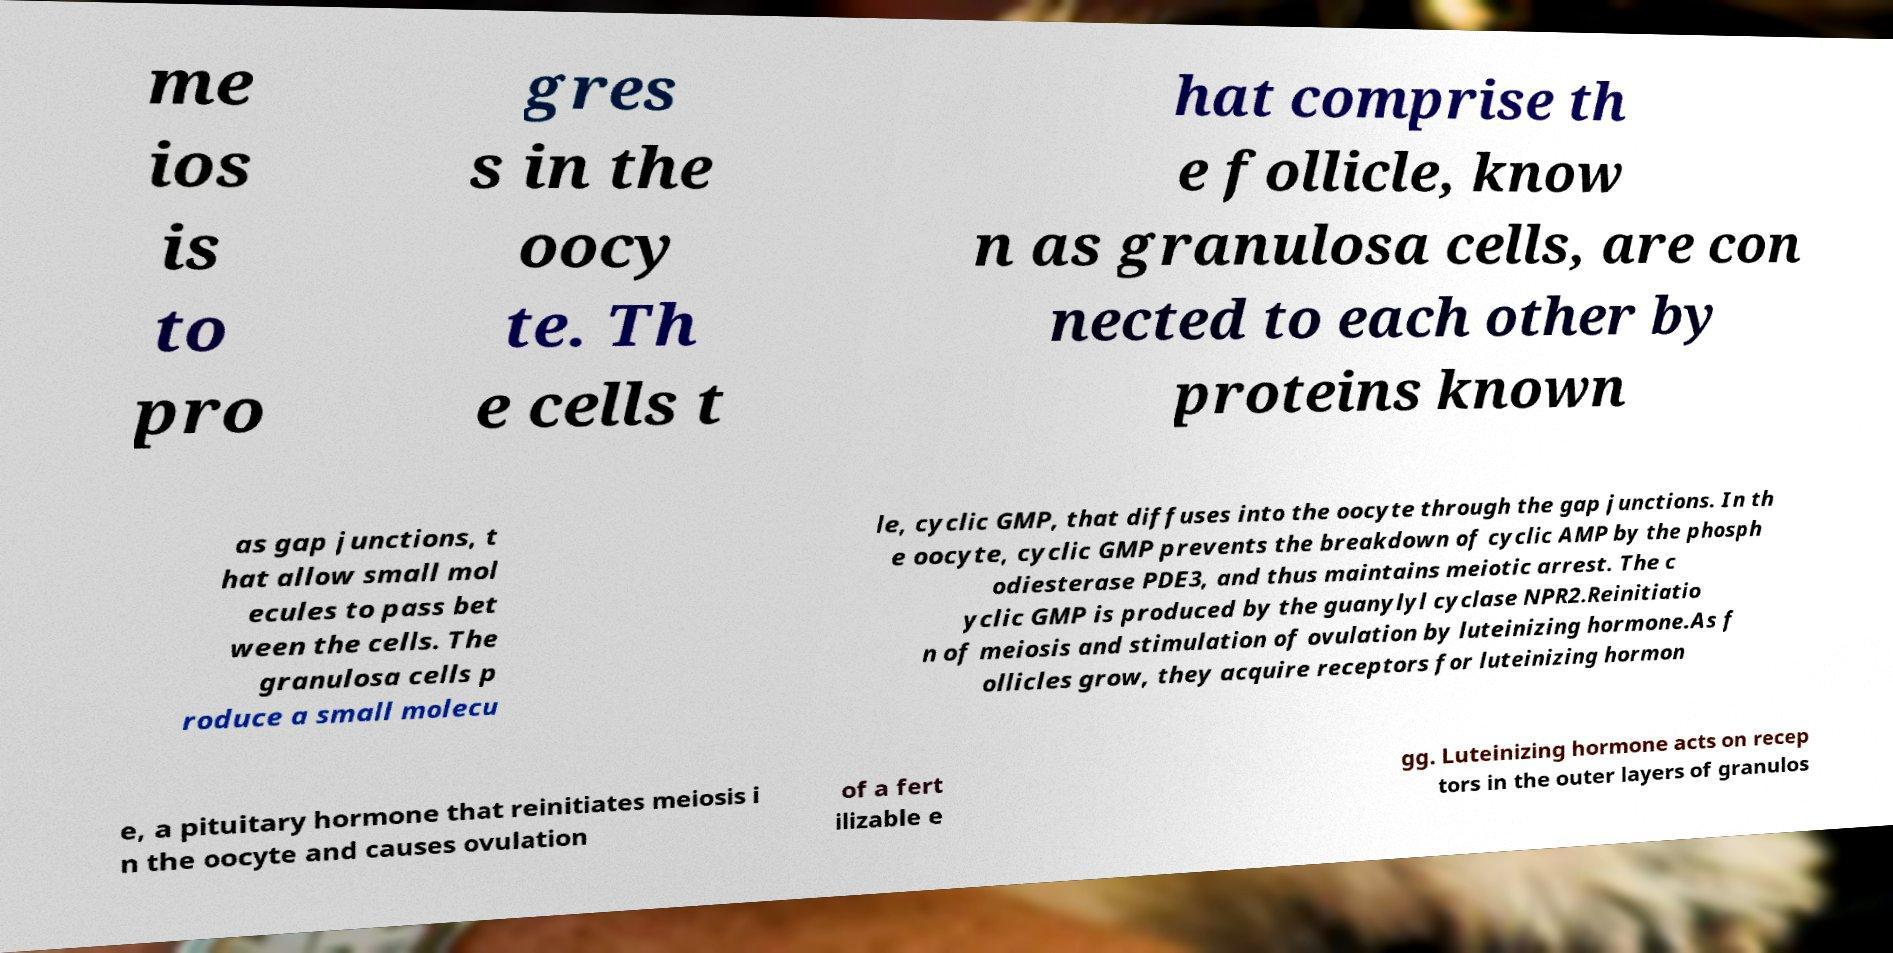Could you assist in decoding the text presented in this image and type it out clearly? me ios is to pro gres s in the oocy te. Th e cells t hat comprise th e follicle, know n as granulosa cells, are con nected to each other by proteins known as gap junctions, t hat allow small mol ecules to pass bet ween the cells. The granulosa cells p roduce a small molecu le, cyclic GMP, that diffuses into the oocyte through the gap junctions. In th e oocyte, cyclic GMP prevents the breakdown of cyclic AMP by the phosph odiesterase PDE3, and thus maintains meiotic arrest. The c yclic GMP is produced by the guanylyl cyclase NPR2.Reinitiatio n of meiosis and stimulation of ovulation by luteinizing hormone.As f ollicles grow, they acquire receptors for luteinizing hormon e, a pituitary hormone that reinitiates meiosis i n the oocyte and causes ovulation of a fert ilizable e gg. Luteinizing hormone acts on recep tors in the outer layers of granulos 